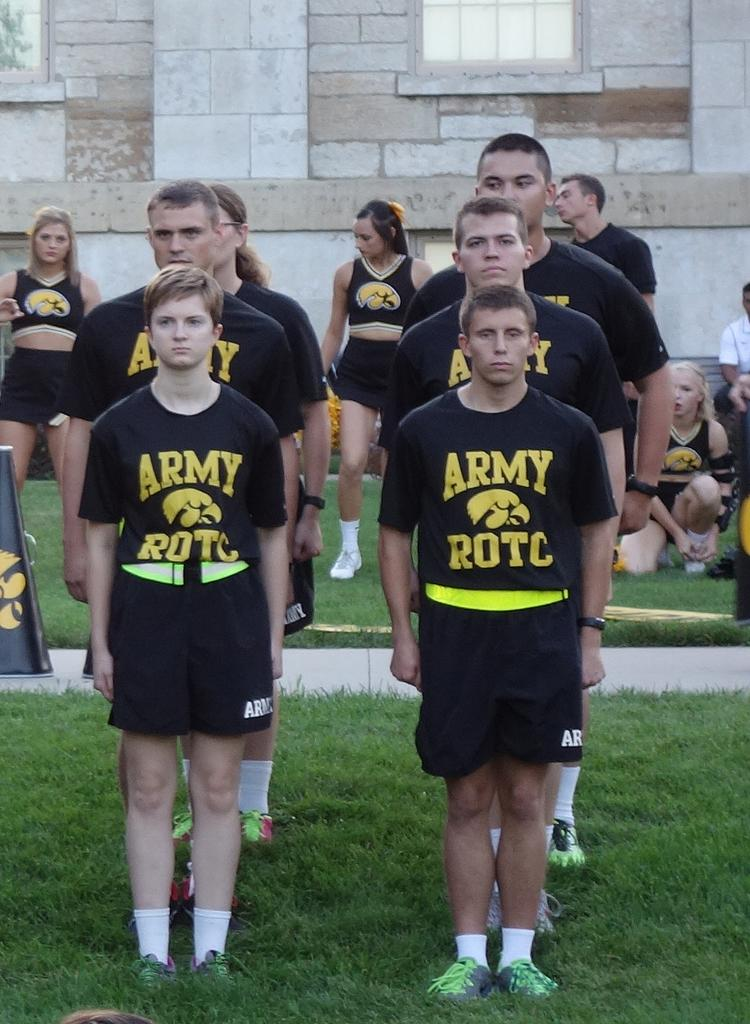How many people are in the image? There is a group of people in the image. What are some of the people in the image doing? Some people are standing on the ground, while others are sitting. What can be seen in the background of the image? There is a wall in the background of the image, and windows are visible. What type of hobbies do the people in the image enjoy? There is no information about the hobbies of the people in the image. What color is the polish on the windows in the image? There is no mention of polish on the windows in the image. 